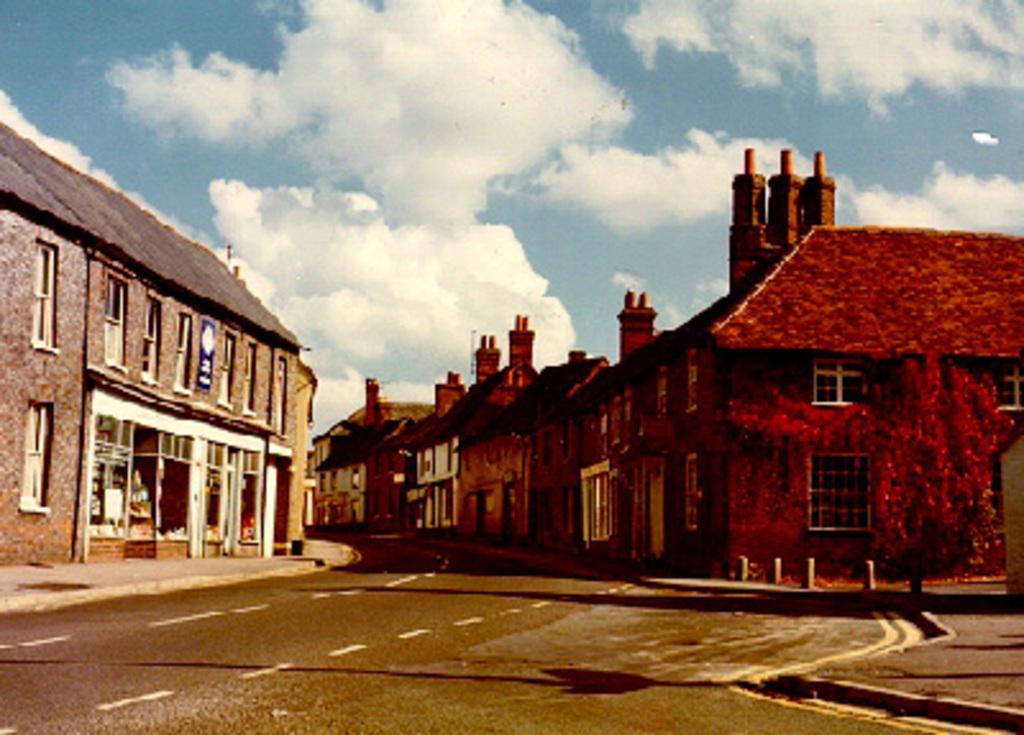How would you summarize this image in a sentence or two? We can see road behind the road there are many buildings , right side building is in red color and lift side building is in light brown color. The sky is full of clouds. 